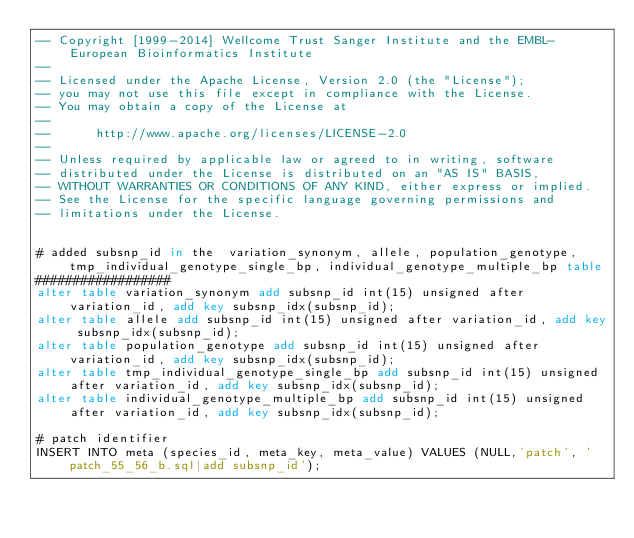Convert code to text. <code><loc_0><loc_0><loc_500><loc_500><_SQL_>-- Copyright [1999-2014] Wellcome Trust Sanger Institute and the EMBL-European Bioinformatics Institute
-- 
-- Licensed under the Apache License, Version 2.0 (the "License");
-- you may not use this file except in compliance with the License.
-- You may obtain a copy of the License at
-- 
--      http://www.apache.org/licenses/LICENSE-2.0
-- 
-- Unless required by applicable law or agreed to in writing, software
-- distributed under the License is distributed on an "AS IS" BASIS,
-- WITHOUT WARRANTIES OR CONDITIONS OF ANY KIND, either express or implied.
-- See the License for the specific language governing permissions and
-- limitations under the License.


# added subsnp_id in the  variation_synonym, allele, population_genotype, tmp_individual_genotype_single_bp, individual_genotype_multiple_bp table
##################
alter table variation_synonym add subsnp_id int(15) unsigned after variation_id, add key subsnp_idx(subsnp_id);
alter table allele add subsnp_id int(15) unsigned after variation_id, add key subsnp_idx(subsnp_id);
alter table population_genotype add subsnp_id int(15) unsigned after variation_id, add key subsnp_idx(subsnp_id);
alter table tmp_individual_genotype_single_bp add subsnp_id int(15) unsigned after variation_id, add key subsnp_idx(subsnp_id);
alter table individual_genotype_multiple_bp add subsnp_id int(15) unsigned after variation_id, add key subsnp_idx(subsnp_id);

# patch identifier
INSERT INTO meta (species_id, meta_key, meta_value) VALUES (NULL,'patch', 'patch_55_56_b.sql|add subsnp_id');
</code> 